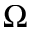Convert formula to latex. <formula><loc_0><loc_0><loc_500><loc_500>\Omega</formula> 